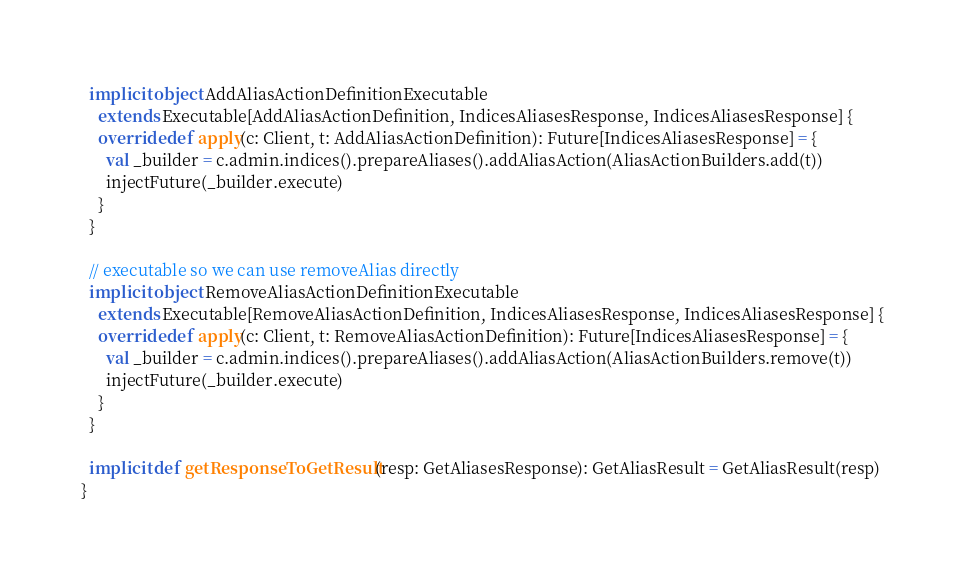<code> <loc_0><loc_0><loc_500><loc_500><_Scala_>  implicit object AddAliasActionDefinitionExecutable
    extends Executable[AddAliasActionDefinition, IndicesAliasesResponse, IndicesAliasesResponse] {
    override def apply(c: Client, t: AddAliasActionDefinition): Future[IndicesAliasesResponse] = {
      val _builder = c.admin.indices().prepareAliases().addAliasAction(AliasActionBuilders.add(t))
      injectFuture(_builder.execute)
    }
  }

  // executable so we can use removeAlias directly
  implicit object RemoveAliasActionDefinitionExecutable
    extends Executable[RemoveAliasActionDefinition, IndicesAliasesResponse, IndicesAliasesResponse] {
    override def apply(c: Client, t: RemoveAliasActionDefinition): Future[IndicesAliasesResponse] = {
      val _builder = c.admin.indices().prepareAliases().addAliasAction(AliasActionBuilders.remove(t))
      injectFuture(_builder.execute)
    }
  }

  implicit def getResponseToGetResult(resp: GetAliasesResponse): GetAliasResult = GetAliasResult(resp)
}
</code> 